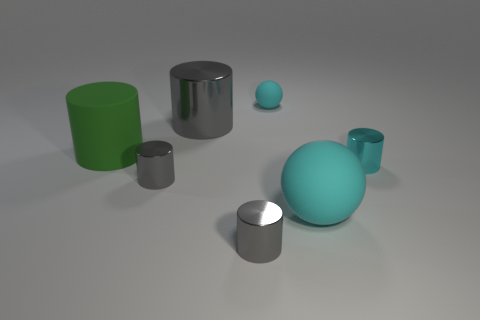Subtract all large metallic cylinders. How many cylinders are left? 4 Subtract all green cylinders. How many cylinders are left? 4 Subtract 1 balls. How many balls are left? 1 Add 3 cyan metal cylinders. How many objects exist? 10 Subtract all cyan balls. How many cyan cylinders are left? 1 Subtract all tiny green shiny blocks. Subtract all cyan balls. How many objects are left? 5 Add 7 cyan balls. How many cyan balls are left? 9 Add 2 rubber cylinders. How many rubber cylinders exist? 3 Subtract 1 cyan cylinders. How many objects are left? 6 Subtract all balls. How many objects are left? 5 